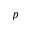Convert formula to latex. <formula><loc_0><loc_0><loc_500><loc_500>p</formula> 